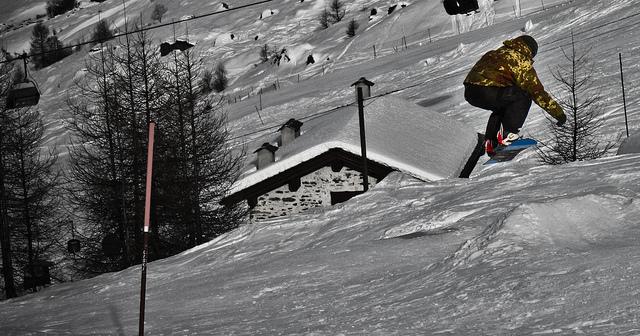Is the person snowboarding?
Quick response, please. Yes. What is on the ground?
Short answer required. Snow. Is this a skiing class?
Concise answer only. No. What is the man doing?
Be succinct. Snowboarding. Is the house buried under snow?
Quick response, please. Yes. Is he holding on?
Answer briefly. No. 